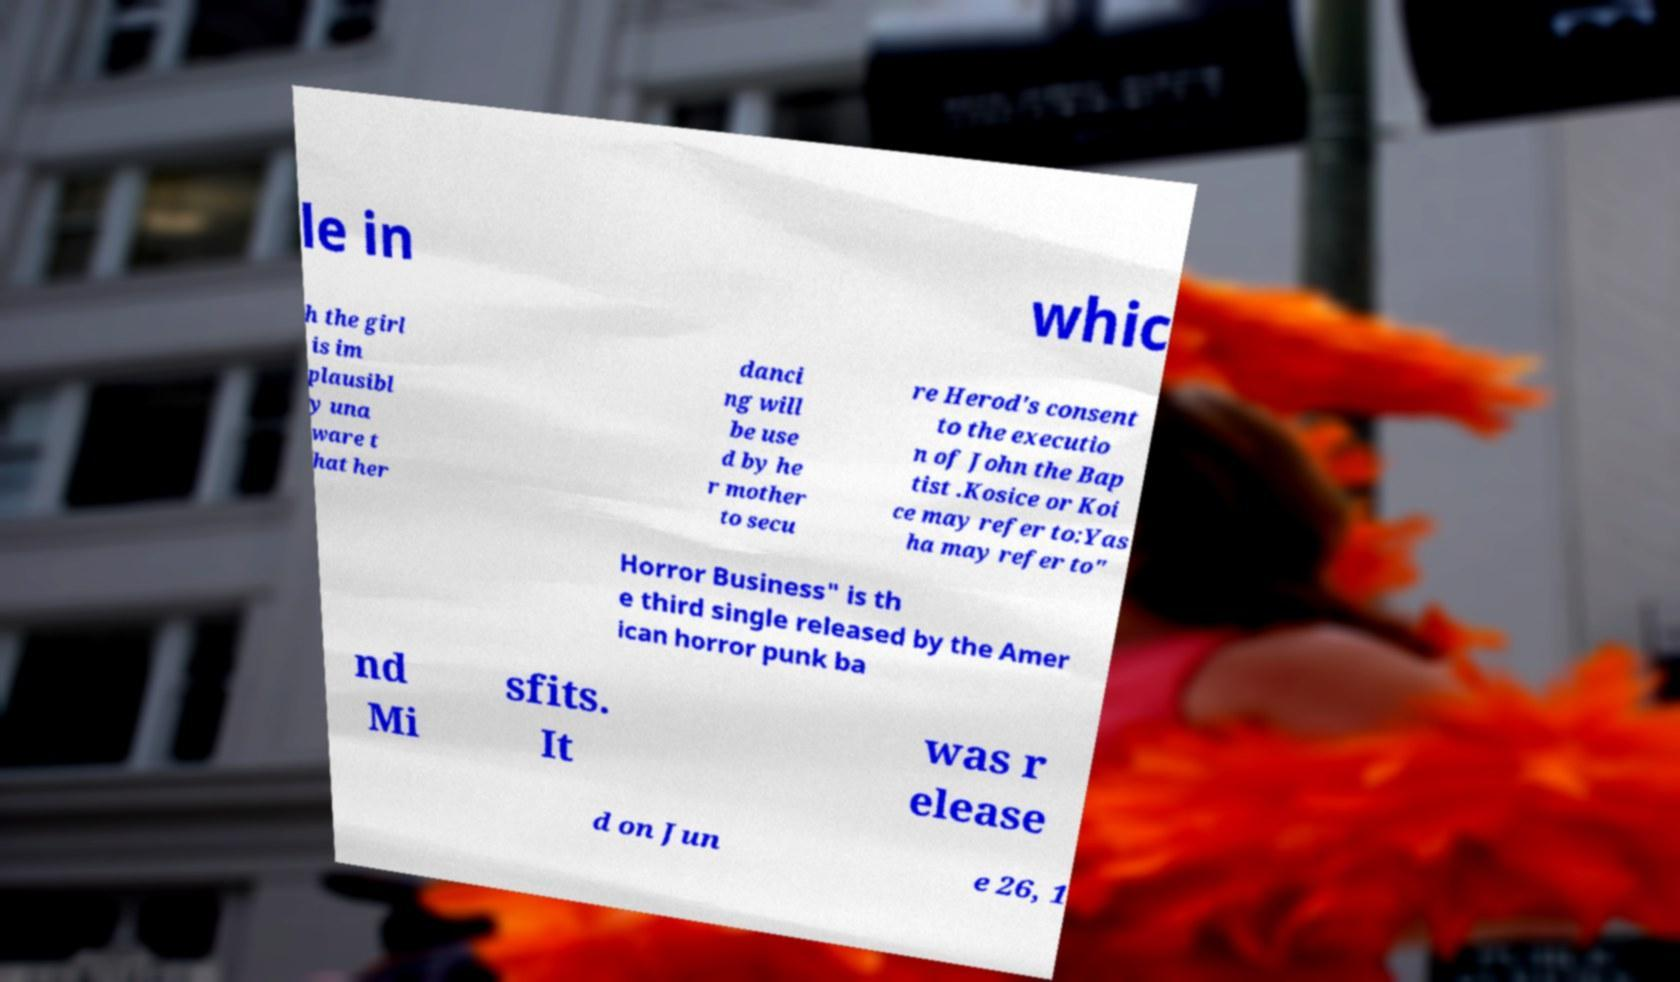For documentation purposes, I need the text within this image transcribed. Could you provide that? le in whic h the girl is im plausibl y una ware t hat her danci ng will be use d by he r mother to secu re Herod's consent to the executio n of John the Bap tist .Kosice or Koi ce may refer to:Yas ha may refer to" Horror Business" is th e third single released by the Amer ican horror punk ba nd Mi sfits. It was r elease d on Jun e 26, 1 